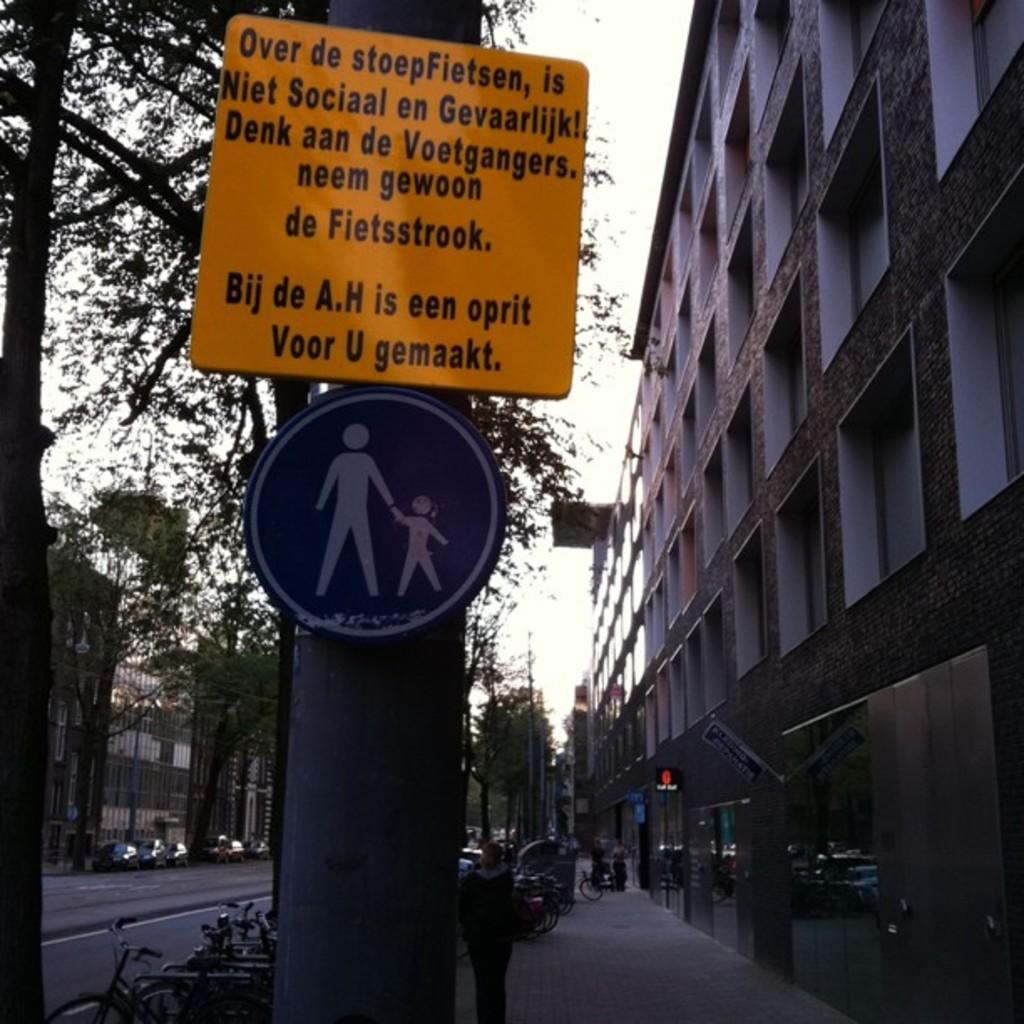<image>
Describe the image concisely. A yellow sign with the first word of Over is posted over a circular sign on the the sidewalk. 